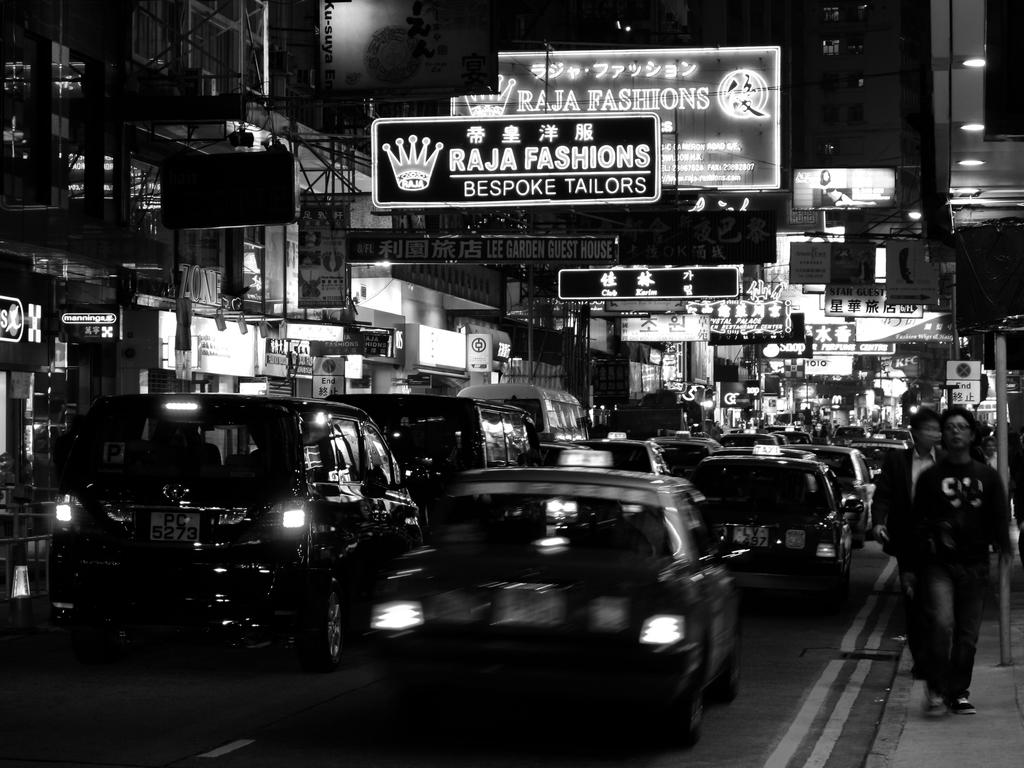<image>
Summarize the visual content of the image. A busy street with a sign hanging over it saying Raja Fashions. 